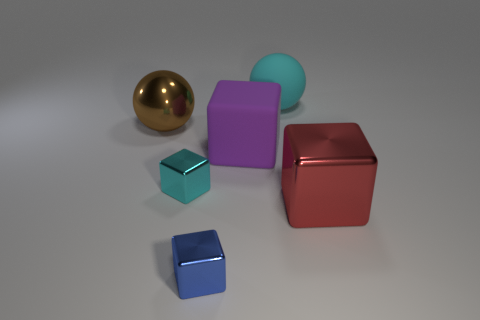Add 4 tiny matte blocks. How many objects exist? 10 Subtract all shiny cubes. How many cubes are left? 1 Subtract all cyan cubes. How many cubes are left? 3 Subtract 0 green balls. How many objects are left? 6 Subtract all balls. How many objects are left? 4 Subtract 1 spheres. How many spheres are left? 1 Subtract all green cubes. Subtract all brown balls. How many cubes are left? 4 Subtract all purple blocks. How many brown balls are left? 1 Subtract all yellow cylinders. Subtract all large blocks. How many objects are left? 4 Add 4 large rubber things. How many large rubber things are left? 6 